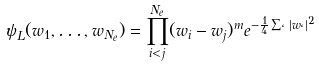<formula> <loc_0><loc_0><loc_500><loc_500>\psi _ { L } ( w _ { 1 } , \dots , w _ { N _ { e } } ) = \prod _ { i < j } ^ { N _ { e } } ( w _ { i } - w _ { j } ) ^ { m } e ^ { - \frac { 1 } { 4 } \sum _ { \ell } | w _ { \ell } | ^ { 2 } }</formula> 